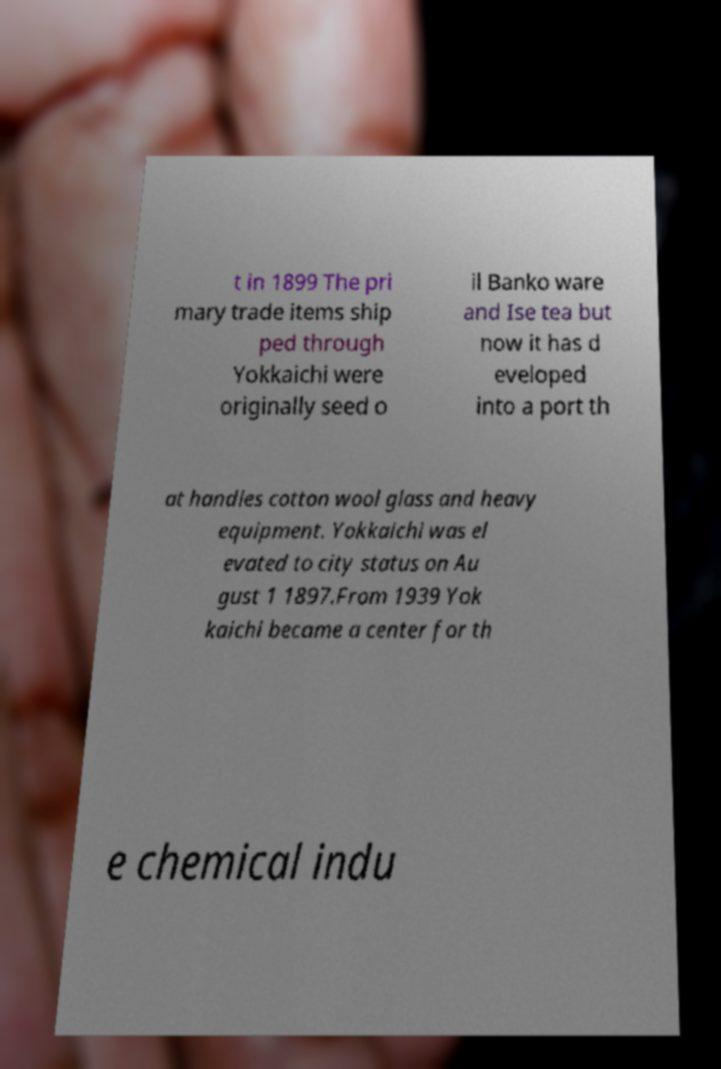What messages or text are displayed in this image? I need them in a readable, typed format. t in 1899 The pri mary trade items ship ped through Yokkaichi were originally seed o il Banko ware and Ise tea but now it has d eveloped into a port th at handles cotton wool glass and heavy equipment. Yokkaichi was el evated to city status on Au gust 1 1897.From 1939 Yok kaichi became a center for th e chemical indu 